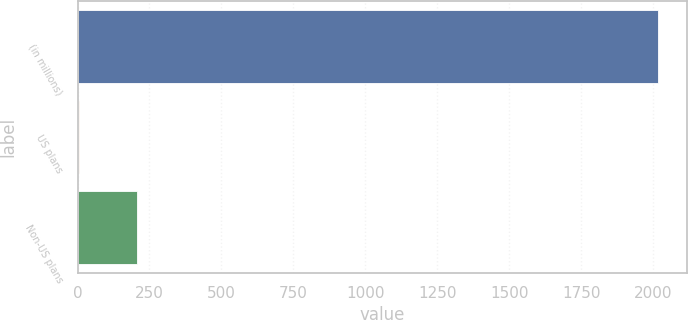<chart> <loc_0><loc_0><loc_500><loc_500><bar_chart><fcel>(in millions)<fcel>US plans<fcel>Non-US plans<nl><fcel>2016<fcel>4<fcel>205.2<nl></chart> 